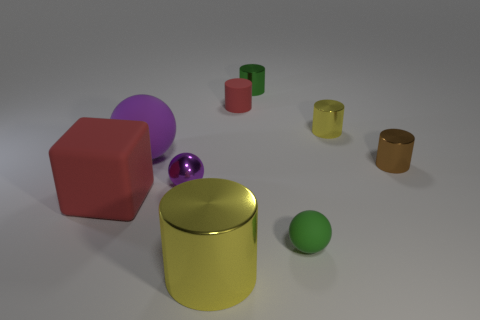Subtract all green cylinders. How many cylinders are left? 4 Subtract all tiny green cylinders. How many cylinders are left? 4 Subtract all purple cylinders. Subtract all brown balls. How many cylinders are left? 5 Subtract all blocks. How many objects are left? 8 Add 8 large blue metal things. How many large blue metal things exist? 8 Subtract 0 blue cylinders. How many objects are left? 9 Subtract all yellow objects. Subtract all small purple shiny things. How many objects are left? 6 Add 9 small matte cylinders. How many small matte cylinders are left? 10 